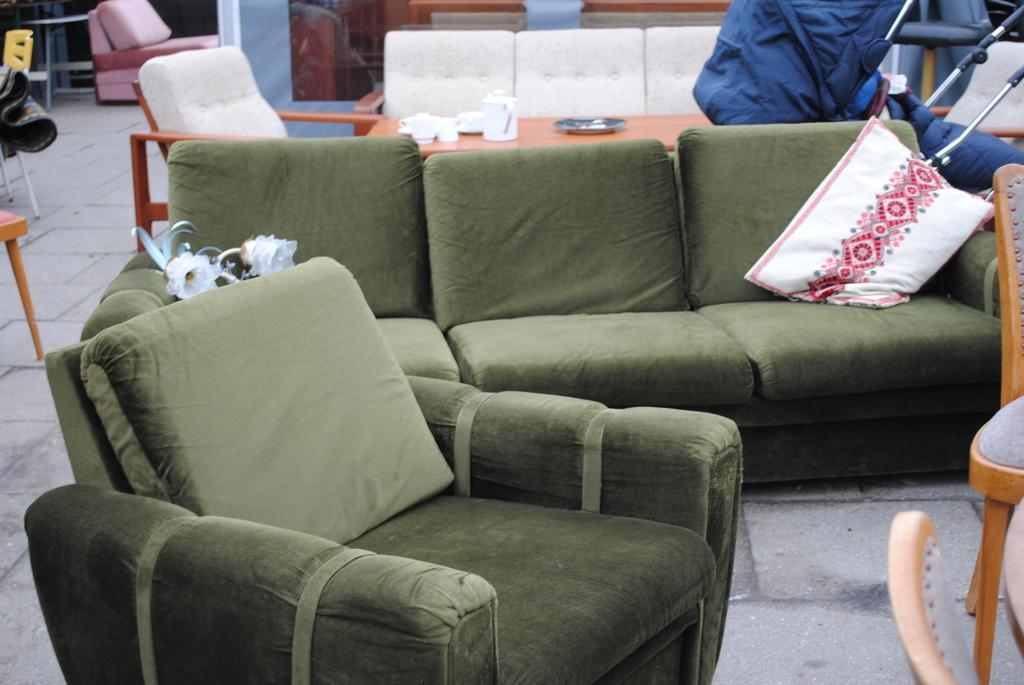What piece of furniture is located in the center of the image? There is a couch in the center of the image. What other furniture can be seen in the background of the image? There is a sofa, a table, and chairs in the background of the image. What type of material is present in the background of the image? There is cloth in the background of the image. What architectural feature is visible in the background of the image? There is a pillar in the background of the image. What object is present in the background of the image that might be used for carrying items? There is a bag in the background of the image. What type of beef is being cooked on the couch in the image? There is no beef or cooking activity present in the image; it features a couch and other furniture and objects. 